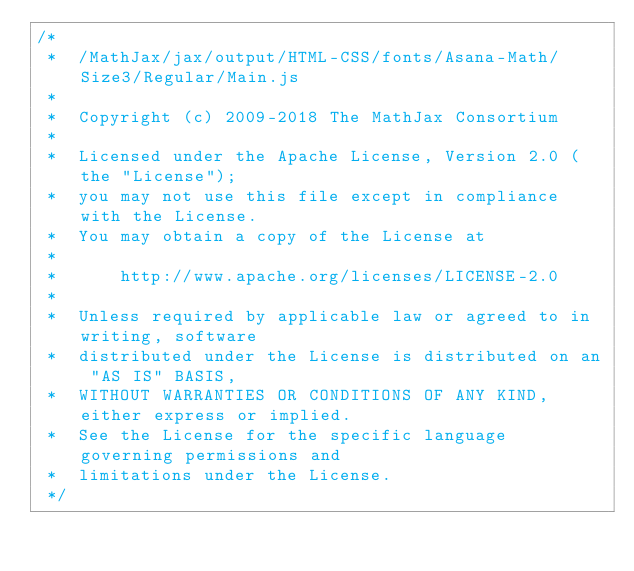<code> <loc_0><loc_0><loc_500><loc_500><_JavaScript_>/*
 *  /MathJax/jax/output/HTML-CSS/fonts/Asana-Math/Size3/Regular/Main.js
 *
 *  Copyright (c) 2009-2018 The MathJax Consortium
 *
 *  Licensed under the Apache License, Version 2.0 (the "License");
 *  you may not use this file except in compliance with the License.
 *  You may obtain a copy of the License at
 *
 *      http://www.apache.org/licenses/LICENSE-2.0
 *
 *  Unless required by applicable law or agreed to in writing, software
 *  distributed under the License is distributed on an "AS IS" BASIS,
 *  WITHOUT WARRANTIES OR CONDITIONS OF ANY KIND, either express or implied.
 *  See the License for the specific language governing permissions and
 *  limitations under the License.
 */
</code> 